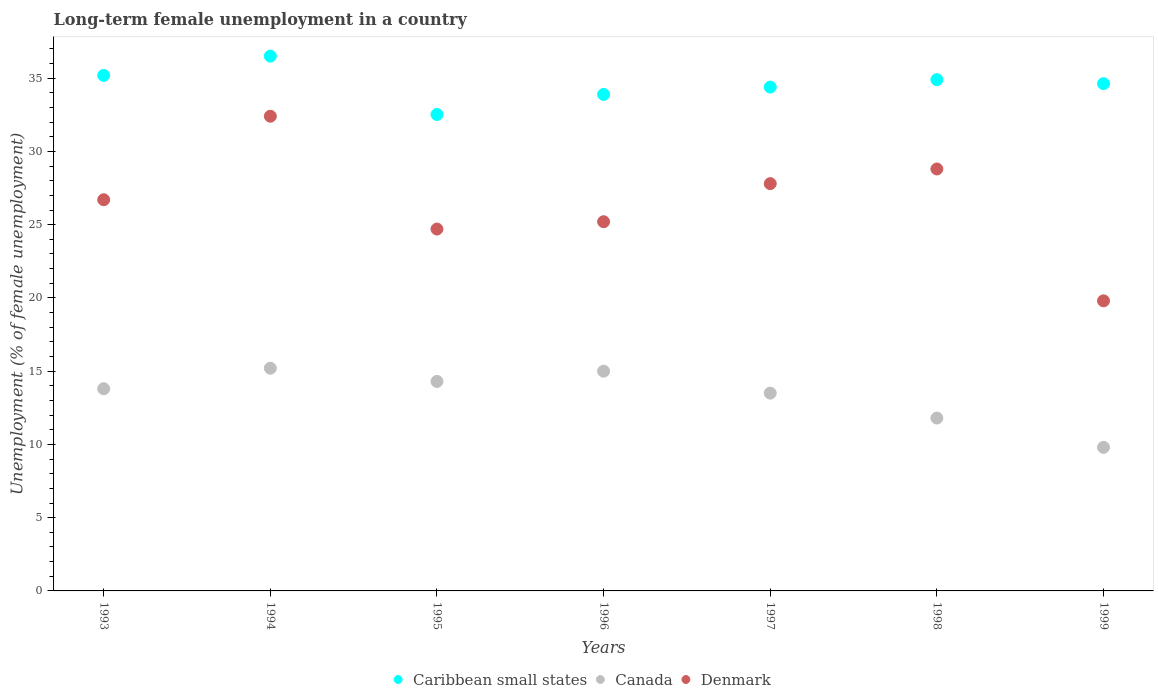Is the number of dotlines equal to the number of legend labels?
Your response must be concise. Yes. What is the percentage of long-term unemployed female population in Denmark in 1997?
Your answer should be very brief. 27.8. Across all years, what is the maximum percentage of long-term unemployed female population in Canada?
Make the answer very short. 15.2. Across all years, what is the minimum percentage of long-term unemployed female population in Canada?
Give a very brief answer. 9.8. In which year was the percentage of long-term unemployed female population in Denmark maximum?
Provide a succinct answer. 1994. What is the total percentage of long-term unemployed female population in Caribbean small states in the graph?
Make the answer very short. 242.01. What is the difference between the percentage of long-term unemployed female population in Canada in 1993 and that in 1999?
Offer a very short reply. 4. What is the difference between the percentage of long-term unemployed female population in Denmark in 1993 and the percentage of long-term unemployed female population in Caribbean small states in 1999?
Your answer should be compact. -7.92. What is the average percentage of long-term unemployed female population in Caribbean small states per year?
Your answer should be very brief. 34.57. In the year 1997, what is the difference between the percentage of long-term unemployed female population in Caribbean small states and percentage of long-term unemployed female population in Canada?
Keep it short and to the point. 20.89. In how many years, is the percentage of long-term unemployed female population in Canada greater than 5 %?
Provide a succinct answer. 7. What is the ratio of the percentage of long-term unemployed female population in Denmark in 1995 to that in 1998?
Give a very brief answer. 0.86. What is the difference between the highest and the second highest percentage of long-term unemployed female population in Denmark?
Ensure brevity in your answer.  3.6. What is the difference between the highest and the lowest percentage of long-term unemployed female population in Caribbean small states?
Provide a succinct answer. 3.98. In how many years, is the percentage of long-term unemployed female population in Canada greater than the average percentage of long-term unemployed female population in Canada taken over all years?
Your answer should be compact. 5. Is the sum of the percentage of long-term unemployed female population in Denmark in 1996 and 1998 greater than the maximum percentage of long-term unemployed female population in Canada across all years?
Your answer should be very brief. Yes. Is it the case that in every year, the sum of the percentage of long-term unemployed female population in Canada and percentage of long-term unemployed female population in Caribbean small states  is greater than the percentage of long-term unemployed female population in Denmark?
Provide a short and direct response. Yes. How many dotlines are there?
Provide a short and direct response. 3. Does the graph contain any zero values?
Give a very brief answer. No. What is the title of the graph?
Make the answer very short. Long-term female unemployment in a country. Does "Greece" appear as one of the legend labels in the graph?
Ensure brevity in your answer.  No. What is the label or title of the X-axis?
Your answer should be very brief. Years. What is the label or title of the Y-axis?
Provide a short and direct response. Unemployment (% of female unemployment). What is the Unemployment (% of female unemployment) of Caribbean small states in 1993?
Your response must be concise. 35.19. What is the Unemployment (% of female unemployment) in Canada in 1993?
Provide a succinct answer. 13.8. What is the Unemployment (% of female unemployment) of Denmark in 1993?
Provide a succinct answer. 26.7. What is the Unemployment (% of female unemployment) of Caribbean small states in 1994?
Keep it short and to the point. 36.5. What is the Unemployment (% of female unemployment) in Canada in 1994?
Your answer should be very brief. 15.2. What is the Unemployment (% of female unemployment) in Denmark in 1994?
Make the answer very short. 32.4. What is the Unemployment (% of female unemployment) in Caribbean small states in 1995?
Offer a very short reply. 32.52. What is the Unemployment (% of female unemployment) of Canada in 1995?
Ensure brevity in your answer.  14.3. What is the Unemployment (% of female unemployment) in Denmark in 1995?
Keep it short and to the point. 24.7. What is the Unemployment (% of female unemployment) of Caribbean small states in 1996?
Offer a very short reply. 33.89. What is the Unemployment (% of female unemployment) of Denmark in 1996?
Ensure brevity in your answer.  25.2. What is the Unemployment (% of female unemployment) in Caribbean small states in 1997?
Your response must be concise. 34.39. What is the Unemployment (% of female unemployment) in Denmark in 1997?
Keep it short and to the point. 27.8. What is the Unemployment (% of female unemployment) in Caribbean small states in 1998?
Your answer should be compact. 34.9. What is the Unemployment (% of female unemployment) of Canada in 1998?
Give a very brief answer. 11.8. What is the Unemployment (% of female unemployment) in Denmark in 1998?
Your response must be concise. 28.8. What is the Unemployment (% of female unemployment) of Caribbean small states in 1999?
Make the answer very short. 34.62. What is the Unemployment (% of female unemployment) in Canada in 1999?
Provide a succinct answer. 9.8. What is the Unemployment (% of female unemployment) in Denmark in 1999?
Provide a short and direct response. 19.8. Across all years, what is the maximum Unemployment (% of female unemployment) in Caribbean small states?
Provide a short and direct response. 36.5. Across all years, what is the maximum Unemployment (% of female unemployment) in Canada?
Ensure brevity in your answer.  15.2. Across all years, what is the maximum Unemployment (% of female unemployment) in Denmark?
Provide a short and direct response. 32.4. Across all years, what is the minimum Unemployment (% of female unemployment) in Caribbean small states?
Your response must be concise. 32.52. Across all years, what is the minimum Unemployment (% of female unemployment) of Canada?
Provide a succinct answer. 9.8. Across all years, what is the minimum Unemployment (% of female unemployment) of Denmark?
Your response must be concise. 19.8. What is the total Unemployment (% of female unemployment) in Caribbean small states in the graph?
Provide a short and direct response. 242.01. What is the total Unemployment (% of female unemployment) in Canada in the graph?
Your response must be concise. 93.4. What is the total Unemployment (% of female unemployment) in Denmark in the graph?
Your answer should be very brief. 185.4. What is the difference between the Unemployment (% of female unemployment) of Caribbean small states in 1993 and that in 1994?
Ensure brevity in your answer.  -1.31. What is the difference between the Unemployment (% of female unemployment) of Canada in 1993 and that in 1994?
Make the answer very short. -1.4. What is the difference between the Unemployment (% of female unemployment) in Denmark in 1993 and that in 1994?
Provide a succinct answer. -5.7. What is the difference between the Unemployment (% of female unemployment) of Caribbean small states in 1993 and that in 1995?
Offer a very short reply. 2.67. What is the difference between the Unemployment (% of female unemployment) of Canada in 1993 and that in 1995?
Give a very brief answer. -0.5. What is the difference between the Unemployment (% of female unemployment) in Caribbean small states in 1993 and that in 1996?
Provide a short and direct response. 1.3. What is the difference between the Unemployment (% of female unemployment) of Denmark in 1993 and that in 1996?
Offer a terse response. 1.5. What is the difference between the Unemployment (% of female unemployment) of Caribbean small states in 1993 and that in 1997?
Provide a short and direct response. 0.8. What is the difference between the Unemployment (% of female unemployment) of Denmark in 1993 and that in 1997?
Provide a succinct answer. -1.1. What is the difference between the Unemployment (% of female unemployment) of Caribbean small states in 1993 and that in 1998?
Make the answer very short. 0.29. What is the difference between the Unemployment (% of female unemployment) of Canada in 1993 and that in 1998?
Your answer should be very brief. 2. What is the difference between the Unemployment (% of female unemployment) in Caribbean small states in 1993 and that in 1999?
Your answer should be very brief. 0.56. What is the difference between the Unemployment (% of female unemployment) in Caribbean small states in 1994 and that in 1995?
Offer a terse response. 3.98. What is the difference between the Unemployment (% of female unemployment) of Canada in 1994 and that in 1995?
Make the answer very short. 0.9. What is the difference between the Unemployment (% of female unemployment) in Caribbean small states in 1994 and that in 1996?
Your response must be concise. 2.61. What is the difference between the Unemployment (% of female unemployment) in Canada in 1994 and that in 1996?
Provide a succinct answer. 0.2. What is the difference between the Unemployment (% of female unemployment) of Caribbean small states in 1994 and that in 1997?
Keep it short and to the point. 2.11. What is the difference between the Unemployment (% of female unemployment) in Caribbean small states in 1994 and that in 1998?
Your response must be concise. 1.6. What is the difference between the Unemployment (% of female unemployment) in Denmark in 1994 and that in 1998?
Offer a very short reply. 3.6. What is the difference between the Unemployment (% of female unemployment) of Caribbean small states in 1994 and that in 1999?
Your response must be concise. 1.88. What is the difference between the Unemployment (% of female unemployment) of Caribbean small states in 1995 and that in 1996?
Your response must be concise. -1.37. What is the difference between the Unemployment (% of female unemployment) of Caribbean small states in 1995 and that in 1997?
Offer a terse response. -1.87. What is the difference between the Unemployment (% of female unemployment) of Caribbean small states in 1995 and that in 1998?
Provide a short and direct response. -2.38. What is the difference between the Unemployment (% of female unemployment) in Denmark in 1995 and that in 1998?
Your response must be concise. -4.1. What is the difference between the Unemployment (% of female unemployment) in Caribbean small states in 1995 and that in 1999?
Provide a succinct answer. -2.1. What is the difference between the Unemployment (% of female unemployment) of Canada in 1995 and that in 1999?
Make the answer very short. 4.5. What is the difference between the Unemployment (% of female unemployment) of Caribbean small states in 1996 and that in 1997?
Your response must be concise. -0.5. What is the difference between the Unemployment (% of female unemployment) of Canada in 1996 and that in 1997?
Your answer should be compact. 1.5. What is the difference between the Unemployment (% of female unemployment) in Caribbean small states in 1996 and that in 1998?
Your answer should be compact. -1.01. What is the difference between the Unemployment (% of female unemployment) of Caribbean small states in 1996 and that in 1999?
Offer a very short reply. -0.73. What is the difference between the Unemployment (% of female unemployment) of Caribbean small states in 1997 and that in 1998?
Provide a short and direct response. -0.51. What is the difference between the Unemployment (% of female unemployment) of Canada in 1997 and that in 1998?
Offer a very short reply. 1.7. What is the difference between the Unemployment (% of female unemployment) of Caribbean small states in 1997 and that in 1999?
Your answer should be very brief. -0.23. What is the difference between the Unemployment (% of female unemployment) of Denmark in 1997 and that in 1999?
Provide a short and direct response. 8. What is the difference between the Unemployment (% of female unemployment) in Caribbean small states in 1998 and that in 1999?
Provide a succinct answer. 0.27. What is the difference between the Unemployment (% of female unemployment) of Denmark in 1998 and that in 1999?
Offer a terse response. 9. What is the difference between the Unemployment (% of female unemployment) of Caribbean small states in 1993 and the Unemployment (% of female unemployment) of Canada in 1994?
Offer a terse response. 19.99. What is the difference between the Unemployment (% of female unemployment) in Caribbean small states in 1993 and the Unemployment (% of female unemployment) in Denmark in 1994?
Offer a very short reply. 2.79. What is the difference between the Unemployment (% of female unemployment) in Canada in 1993 and the Unemployment (% of female unemployment) in Denmark in 1994?
Your response must be concise. -18.6. What is the difference between the Unemployment (% of female unemployment) of Caribbean small states in 1993 and the Unemployment (% of female unemployment) of Canada in 1995?
Make the answer very short. 20.89. What is the difference between the Unemployment (% of female unemployment) in Caribbean small states in 1993 and the Unemployment (% of female unemployment) in Denmark in 1995?
Give a very brief answer. 10.49. What is the difference between the Unemployment (% of female unemployment) of Canada in 1993 and the Unemployment (% of female unemployment) of Denmark in 1995?
Keep it short and to the point. -10.9. What is the difference between the Unemployment (% of female unemployment) of Caribbean small states in 1993 and the Unemployment (% of female unemployment) of Canada in 1996?
Offer a very short reply. 20.19. What is the difference between the Unemployment (% of female unemployment) of Caribbean small states in 1993 and the Unemployment (% of female unemployment) of Denmark in 1996?
Your answer should be compact. 9.99. What is the difference between the Unemployment (% of female unemployment) of Canada in 1993 and the Unemployment (% of female unemployment) of Denmark in 1996?
Provide a succinct answer. -11.4. What is the difference between the Unemployment (% of female unemployment) in Caribbean small states in 1993 and the Unemployment (% of female unemployment) in Canada in 1997?
Provide a short and direct response. 21.69. What is the difference between the Unemployment (% of female unemployment) of Caribbean small states in 1993 and the Unemployment (% of female unemployment) of Denmark in 1997?
Offer a terse response. 7.39. What is the difference between the Unemployment (% of female unemployment) of Canada in 1993 and the Unemployment (% of female unemployment) of Denmark in 1997?
Ensure brevity in your answer.  -14. What is the difference between the Unemployment (% of female unemployment) of Caribbean small states in 1993 and the Unemployment (% of female unemployment) of Canada in 1998?
Offer a terse response. 23.39. What is the difference between the Unemployment (% of female unemployment) in Caribbean small states in 1993 and the Unemployment (% of female unemployment) in Denmark in 1998?
Make the answer very short. 6.39. What is the difference between the Unemployment (% of female unemployment) of Canada in 1993 and the Unemployment (% of female unemployment) of Denmark in 1998?
Provide a short and direct response. -15. What is the difference between the Unemployment (% of female unemployment) of Caribbean small states in 1993 and the Unemployment (% of female unemployment) of Canada in 1999?
Ensure brevity in your answer.  25.39. What is the difference between the Unemployment (% of female unemployment) in Caribbean small states in 1993 and the Unemployment (% of female unemployment) in Denmark in 1999?
Ensure brevity in your answer.  15.39. What is the difference between the Unemployment (% of female unemployment) of Canada in 1993 and the Unemployment (% of female unemployment) of Denmark in 1999?
Ensure brevity in your answer.  -6. What is the difference between the Unemployment (% of female unemployment) of Caribbean small states in 1994 and the Unemployment (% of female unemployment) of Canada in 1995?
Your answer should be compact. 22.2. What is the difference between the Unemployment (% of female unemployment) in Caribbean small states in 1994 and the Unemployment (% of female unemployment) in Denmark in 1995?
Your answer should be very brief. 11.8. What is the difference between the Unemployment (% of female unemployment) of Canada in 1994 and the Unemployment (% of female unemployment) of Denmark in 1995?
Provide a short and direct response. -9.5. What is the difference between the Unemployment (% of female unemployment) of Caribbean small states in 1994 and the Unemployment (% of female unemployment) of Canada in 1996?
Give a very brief answer. 21.5. What is the difference between the Unemployment (% of female unemployment) of Caribbean small states in 1994 and the Unemployment (% of female unemployment) of Denmark in 1996?
Your response must be concise. 11.3. What is the difference between the Unemployment (% of female unemployment) of Canada in 1994 and the Unemployment (% of female unemployment) of Denmark in 1996?
Keep it short and to the point. -10. What is the difference between the Unemployment (% of female unemployment) in Caribbean small states in 1994 and the Unemployment (% of female unemployment) in Canada in 1997?
Keep it short and to the point. 23. What is the difference between the Unemployment (% of female unemployment) of Caribbean small states in 1994 and the Unemployment (% of female unemployment) of Denmark in 1997?
Your response must be concise. 8.7. What is the difference between the Unemployment (% of female unemployment) of Caribbean small states in 1994 and the Unemployment (% of female unemployment) of Canada in 1998?
Give a very brief answer. 24.7. What is the difference between the Unemployment (% of female unemployment) of Caribbean small states in 1994 and the Unemployment (% of female unemployment) of Denmark in 1998?
Provide a succinct answer. 7.7. What is the difference between the Unemployment (% of female unemployment) in Canada in 1994 and the Unemployment (% of female unemployment) in Denmark in 1998?
Ensure brevity in your answer.  -13.6. What is the difference between the Unemployment (% of female unemployment) in Caribbean small states in 1994 and the Unemployment (% of female unemployment) in Canada in 1999?
Keep it short and to the point. 26.7. What is the difference between the Unemployment (% of female unemployment) in Caribbean small states in 1994 and the Unemployment (% of female unemployment) in Denmark in 1999?
Give a very brief answer. 16.7. What is the difference between the Unemployment (% of female unemployment) in Caribbean small states in 1995 and the Unemployment (% of female unemployment) in Canada in 1996?
Provide a short and direct response. 17.52. What is the difference between the Unemployment (% of female unemployment) in Caribbean small states in 1995 and the Unemployment (% of female unemployment) in Denmark in 1996?
Your response must be concise. 7.32. What is the difference between the Unemployment (% of female unemployment) of Caribbean small states in 1995 and the Unemployment (% of female unemployment) of Canada in 1997?
Provide a succinct answer. 19.02. What is the difference between the Unemployment (% of female unemployment) in Caribbean small states in 1995 and the Unemployment (% of female unemployment) in Denmark in 1997?
Your answer should be compact. 4.72. What is the difference between the Unemployment (% of female unemployment) in Caribbean small states in 1995 and the Unemployment (% of female unemployment) in Canada in 1998?
Keep it short and to the point. 20.72. What is the difference between the Unemployment (% of female unemployment) in Caribbean small states in 1995 and the Unemployment (% of female unemployment) in Denmark in 1998?
Offer a very short reply. 3.72. What is the difference between the Unemployment (% of female unemployment) in Canada in 1995 and the Unemployment (% of female unemployment) in Denmark in 1998?
Make the answer very short. -14.5. What is the difference between the Unemployment (% of female unemployment) in Caribbean small states in 1995 and the Unemployment (% of female unemployment) in Canada in 1999?
Offer a very short reply. 22.72. What is the difference between the Unemployment (% of female unemployment) in Caribbean small states in 1995 and the Unemployment (% of female unemployment) in Denmark in 1999?
Provide a succinct answer. 12.72. What is the difference between the Unemployment (% of female unemployment) of Canada in 1995 and the Unemployment (% of female unemployment) of Denmark in 1999?
Offer a very short reply. -5.5. What is the difference between the Unemployment (% of female unemployment) in Caribbean small states in 1996 and the Unemployment (% of female unemployment) in Canada in 1997?
Provide a succinct answer. 20.39. What is the difference between the Unemployment (% of female unemployment) in Caribbean small states in 1996 and the Unemployment (% of female unemployment) in Denmark in 1997?
Make the answer very short. 6.09. What is the difference between the Unemployment (% of female unemployment) of Canada in 1996 and the Unemployment (% of female unemployment) of Denmark in 1997?
Ensure brevity in your answer.  -12.8. What is the difference between the Unemployment (% of female unemployment) in Caribbean small states in 1996 and the Unemployment (% of female unemployment) in Canada in 1998?
Offer a terse response. 22.09. What is the difference between the Unemployment (% of female unemployment) of Caribbean small states in 1996 and the Unemployment (% of female unemployment) of Denmark in 1998?
Offer a terse response. 5.09. What is the difference between the Unemployment (% of female unemployment) in Caribbean small states in 1996 and the Unemployment (% of female unemployment) in Canada in 1999?
Your answer should be very brief. 24.09. What is the difference between the Unemployment (% of female unemployment) of Caribbean small states in 1996 and the Unemployment (% of female unemployment) of Denmark in 1999?
Make the answer very short. 14.09. What is the difference between the Unemployment (% of female unemployment) of Canada in 1996 and the Unemployment (% of female unemployment) of Denmark in 1999?
Your answer should be compact. -4.8. What is the difference between the Unemployment (% of female unemployment) in Caribbean small states in 1997 and the Unemployment (% of female unemployment) in Canada in 1998?
Your response must be concise. 22.59. What is the difference between the Unemployment (% of female unemployment) of Caribbean small states in 1997 and the Unemployment (% of female unemployment) of Denmark in 1998?
Provide a short and direct response. 5.59. What is the difference between the Unemployment (% of female unemployment) of Canada in 1997 and the Unemployment (% of female unemployment) of Denmark in 1998?
Your answer should be compact. -15.3. What is the difference between the Unemployment (% of female unemployment) in Caribbean small states in 1997 and the Unemployment (% of female unemployment) in Canada in 1999?
Provide a succinct answer. 24.59. What is the difference between the Unemployment (% of female unemployment) in Caribbean small states in 1997 and the Unemployment (% of female unemployment) in Denmark in 1999?
Your response must be concise. 14.59. What is the difference between the Unemployment (% of female unemployment) in Canada in 1997 and the Unemployment (% of female unemployment) in Denmark in 1999?
Provide a short and direct response. -6.3. What is the difference between the Unemployment (% of female unemployment) in Caribbean small states in 1998 and the Unemployment (% of female unemployment) in Canada in 1999?
Provide a succinct answer. 25.1. What is the difference between the Unemployment (% of female unemployment) of Caribbean small states in 1998 and the Unemployment (% of female unemployment) of Denmark in 1999?
Your answer should be compact. 15.1. What is the difference between the Unemployment (% of female unemployment) of Canada in 1998 and the Unemployment (% of female unemployment) of Denmark in 1999?
Your answer should be compact. -8. What is the average Unemployment (% of female unemployment) of Caribbean small states per year?
Your response must be concise. 34.57. What is the average Unemployment (% of female unemployment) of Canada per year?
Provide a short and direct response. 13.34. What is the average Unemployment (% of female unemployment) of Denmark per year?
Keep it short and to the point. 26.49. In the year 1993, what is the difference between the Unemployment (% of female unemployment) in Caribbean small states and Unemployment (% of female unemployment) in Canada?
Offer a terse response. 21.39. In the year 1993, what is the difference between the Unemployment (% of female unemployment) of Caribbean small states and Unemployment (% of female unemployment) of Denmark?
Your answer should be very brief. 8.49. In the year 1993, what is the difference between the Unemployment (% of female unemployment) in Canada and Unemployment (% of female unemployment) in Denmark?
Provide a succinct answer. -12.9. In the year 1994, what is the difference between the Unemployment (% of female unemployment) of Caribbean small states and Unemployment (% of female unemployment) of Canada?
Ensure brevity in your answer.  21.3. In the year 1994, what is the difference between the Unemployment (% of female unemployment) in Caribbean small states and Unemployment (% of female unemployment) in Denmark?
Ensure brevity in your answer.  4.1. In the year 1994, what is the difference between the Unemployment (% of female unemployment) in Canada and Unemployment (% of female unemployment) in Denmark?
Offer a very short reply. -17.2. In the year 1995, what is the difference between the Unemployment (% of female unemployment) of Caribbean small states and Unemployment (% of female unemployment) of Canada?
Offer a very short reply. 18.22. In the year 1995, what is the difference between the Unemployment (% of female unemployment) in Caribbean small states and Unemployment (% of female unemployment) in Denmark?
Ensure brevity in your answer.  7.82. In the year 1995, what is the difference between the Unemployment (% of female unemployment) in Canada and Unemployment (% of female unemployment) in Denmark?
Give a very brief answer. -10.4. In the year 1996, what is the difference between the Unemployment (% of female unemployment) of Caribbean small states and Unemployment (% of female unemployment) of Canada?
Your answer should be very brief. 18.89. In the year 1996, what is the difference between the Unemployment (% of female unemployment) in Caribbean small states and Unemployment (% of female unemployment) in Denmark?
Provide a short and direct response. 8.69. In the year 1997, what is the difference between the Unemployment (% of female unemployment) in Caribbean small states and Unemployment (% of female unemployment) in Canada?
Your answer should be very brief. 20.89. In the year 1997, what is the difference between the Unemployment (% of female unemployment) in Caribbean small states and Unemployment (% of female unemployment) in Denmark?
Keep it short and to the point. 6.59. In the year 1997, what is the difference between the Unemployment (% of female unemployment) of Canada and Unemployment (% of female unemployment) of Denmark?
Ensure brevity in your answer.  -14.3. In the year 1998, what is the difference between the Unemployment (% of female unemployment) in Caribbean small states and Unemployment (% of female unemployment) in Canada?
Your answer should be very brief. 23.1. In the year 1998, what is the difference between the Unemployment (% of female unemployment) in Caribbean small states and Unemployment (% of female unemployment) in Denmark?
Your answer should be very brief. 6.1. In the year 1999, what is the difference between the Unemployment (% of female unemployment) of Caribbean small states and Unemployment (% of female unemployment) of Canada?
Ensure brevity in your answer.  24.82. In the year 1999, what is the difference between the Unemployment (% of female unemployment) in Caribbean small states and Unemployment (% of female unemployment) in Denmark?
Give a very brief answer. 14.82. In the year 1999, what is the difference between the Unemployment (% of female unemployment) of Canada and Unemployment (% of female unemployment) of Denmark?
Your answer should be compact. -10. What is the ratio of the Unemployment (% of female unemployment) of Canada in 1993 to that in 1994?
Give a very brief answer. 0.91. What is the ratio of the Unemployment (% of female unemployment) in Denmark in 1993 to that in 1994?
Ensure brevity in your answer.  0.82. What is the ratio of the Unemployment (% of female unemployment) of Caribbean small states in 1993 to that in 1995?
Your answer should be compact. 1.08. What is the ratio of the Unemployment (% of female unemployment) of Denmark in 1993 to that in 1995?
Keep it short and to the point. 1.08. What is the ratio of the Unemployment (% of female unemployment) in Caribbean small states in 1993 to that in 1996?
Keep it short and to the point. 1.04. What is the ratio of the Unemployment (% of female unemployment) of Denmark in 1993 to that in 1996?
Provide a short and direct response. 1.06. What is the ratio of the Unemployment (% of female unemployment) in Caribbean small states in 1993 to that in 1997?
Keep it short and to the point. 1.02. What is the ratio of the Unemployment (% of female unemployment) in Canada in 1993 to that in 1997?
Offer a very short reply. 1.02. What is the ratio of the Unemployment (% of female unemployment) of Denmark in 1993 to that in 1997?
Give a very brief answer. 0.96. What is the ratio of the Unemployment (% of female unemployment) of Caribbean small states in 1993 to that in 1998?
Your answer should be compact. 1.01. What is the ratio of the Unemployment (% of female unemployment) in Canada in 1993 to that in 1998?
Make the answer very short. 1.17. What is the ratio of the Unemployment (% of female unemployment) in Denmark in 1993 to that in 1998?
Your answer should be compact. 0.93. What is the ratio of the Unemployment (% of female unemployment) of Caribbean small states in 1993 to that in 1999?
Your answer should be very brief. 1.02. What is the ratio of the Unemployment (% of female unemployment) of Canada in 1993 to that in 1999?
Give a very brief answer. 1.41. What is the ratio of the Unemployment (% of female unemployment) in Denmark in 1993 to that in 1999?
Your answer should be very brief. 1.35. What is the ratio of the Unemployment (% of female unemployment) in Caribbean small states in 1994 to that in 1995?
Give a very brief answer. 1.12. What is the ratio of the Unemployment (% of female unemployment) in Canada in 1994 to that in 1995?
Offer a terse response. 1.06. What is the ratio of the Unemployment (% of female unemployment) in Denmark in 1994 to that in 1995?
Keep it short and to the point. 1.31. What is the ratio of the Unemployment (% of female unemployment) in Caribbean small states in 1994 to that in 1996?
Ensure brevity in your answer.  1.08. What is the ratio of the Unemployment (% of female unemployment) of Canada in 1994 to that in 1996?
Offer a terse response. 1.01. What is the ratio of the Unemployment (% of female unemployment) in Denmark in 1994 to that in 1996?
Ensure brevity in your answer.  1.29. What is the ratio of the Unemployment (% of female unemployment) of Caribbean small states in 1994 to that in 1997?
Ensure brevity in your answer.  1.06. What is the ratio of the Unemployment (% of female unemployment) in Canada in 1994 to that in 1997?
Provide a short and direct response. 1.13. What is the ratio of the Unemployment (% of female unemployment) of Denmark in 1994 to that in 1997?
Offer a very short reply. 1.17. What is the ratio of the Unemployment (% of female unemployment) of Caribbean small states in 1994 to that in 1998?
Keep it short and to the point. 1.05. What is the ratio of the Unemployment (% of female unemployment) of Canada in 1994 to that in 1998?
Offer a very short reply. 1.29. What is the ratio of the Unemployment (% of female unemployment) in Caribbean small states in 1994 to that in 1999?
Ensure brevity in your answer.  1.05. What is the ratio of the Unemployment (% of female unemployment) of Canada in 1994 to that in 1999?
Your answer should be very brief. 1.55. What is the ratio of the Unemployment (% of female unemployment) in Denmark in 1994 to that in 1999?
Provide a succinct answer. 1.64. What is the ratio of the Unemployment (% of female unemployment) in Caribbean small states in 1995 to that in 1996?
Provide a succinct answer. 0.96. What is the ratio of the Unemployment (% of female unemployment) in Canada in 1995 to that in 1996?
Your answer should be very brief. 0.95. What is the ratio of the Unemployment (% of female unemployment) in Denmark in 1995 to that in 1996?
Offer a terse response. 0.98. What is the ratio of the Unemployment (% of female unemployment) of Caribbean small states in 1995 to that in 1997?
Provide a succinct answer. 0.95. What is the ratio of the Unemployment (% of female unemployment) of Canada in 1995 to that in 1997?
Your response must be concise. 1.06. What is the ratio of the Unemployment (% of female unemployment) of Denmark in 1995 to that in 1997?
Provide a short and direct response. 0.89. What is the ratio of the Unemployment (% of female unemployment) of Caribbean small states in 1995 to that in 1998?
Keep it short and to the point. 0.93. What is the ratio of the Unemployment (% of female unemployment) in Canada in 1995 to that in 1998?
Your response must be concise. 1.21. What is the ratio of the Unemployment (% of female unemployment) in Denmark in 1995 to that in 1998?
Make the answer very short. 0.86. What is the ratio of the Unemployment (% of female unemployment) of Caribbean small states in 1995 to that in 1999?
Provide a short and direct response. 0.94. What is the ratio of the Unemployment (% of female unemployment) of Canada in 1995 to that in 1999?
Offer a terse response. 1.46. What is the ratio of the Unemployment (% of female unemployment) of Denmark in 1995 to that in 1999?
Your response must be concise. 1.25. What is the ratio of the Unemployment (% of female unemployment) of Caribbean small states in 1996 to that in 1997?
Your answer should be compact. 0.99. What is the ratio of the Unemployment (% of female unemployment) of Denmark in 1996 to that in 1997?
Your answer should be very brief. 0.91. What is the ratio of the Unemployment (% of female unemployment) of Caribbean small states in 1996 to that in 1998?
Ensure brevity in your answer.  0.97. What is the ratio of the Unemployment (% of female unemployment) of Canada in 1996 to that in 1998?
Give a very brief answer. 1.27. What is the ratio of the Unemployment (% of female unemployment) of Denmark in 1996 to that in 1998?
Keep it short and to the point. 0.88. What is the ratio of the Unemployment (% of female unemployment) of Caribbean small states in 1996 to that in 1999?
Make the answer very short. 0.98. What is the ratio of the Unemployment (% of female unemployment) of Canada in 1996 to that in 1999?
Give a very brief answer. 1.53. What is the ratio of the Unemployment (% of female unemployment) of Denmark in 1996 to that in 1999?
Ensure brevity in your answer.  1.27. What is the ratio of the Unemployment (% of female unemployment) in Caribbean small states in 1997 to that in 1998?
Provide a short and direct response. 0.99. What is the ratio of the Unemployment (% of female unemployment) in Canada in 1997 to that in 1998?
Offer a very short reply. 1.14. What is the ratio of the Unemployment (% of female unemployment) in Denmark in 1997 to that in 1998?
Your response must be concise. 0.97. What is the ratio of the Unemployment (% of female unemployment) in Canada in 1997 to that in 1999?
Your answer should be compact. 1.38. What is the ratio of the Unemployment (% of female unemployment) of Denmark in 1997 to that in 1999?
Give a very brief answer. 1.4. What is the ratio of the Unemployment (% of female unemployment) in Caribbean small states in 1998 to that in 1999?
Offer a very short reply. 1.01. What is the ratio of the Unemployment (% of female unemployment) in Canada in 1998 to that in 1999?
Provide a short and direct response. 1.2. What is the ratio of the Unemployment (% of female unemployment) in Denmark in 1998 to that in 1999?
Offer a terse response. 1.45. What is the difference between the highest and the second highest Unemployment (% of female unemployment) of Caribbean small states?
Offer a terse response. 1.31. What is the difference between the highest and the lowest Unemployment (% of female unemployment) in Caribbean small states?
Give a very brief answer. 3.98. What is the difference between the highest and the lowest Unemployment (% of female unemployment) in Denmark?
Make the answer very short. 12.6. 